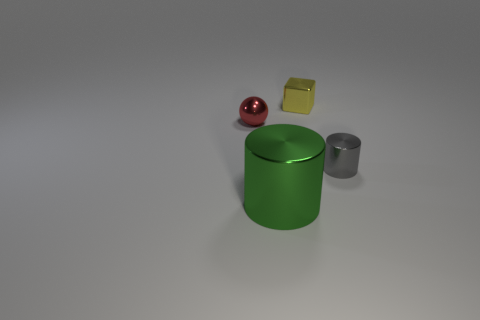Add 2 small cyan matte cylinders. How many objects exist? 6 Subtract all cubes. How many objects are left? 3 Subtract 0 red blocks. How many objects are left? 4 Subtract all metal blocks. Subtract all tiny things. How many objects are left? 0 Add 3 small yellow things. How many small yellow things are left? 4 Add 3 cylinders. How many cylinders exist? 5 